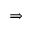Convert formula to latex. <formula><loc_0><loc_0><loc_500><loc_500>\Rightarrow</formula> 